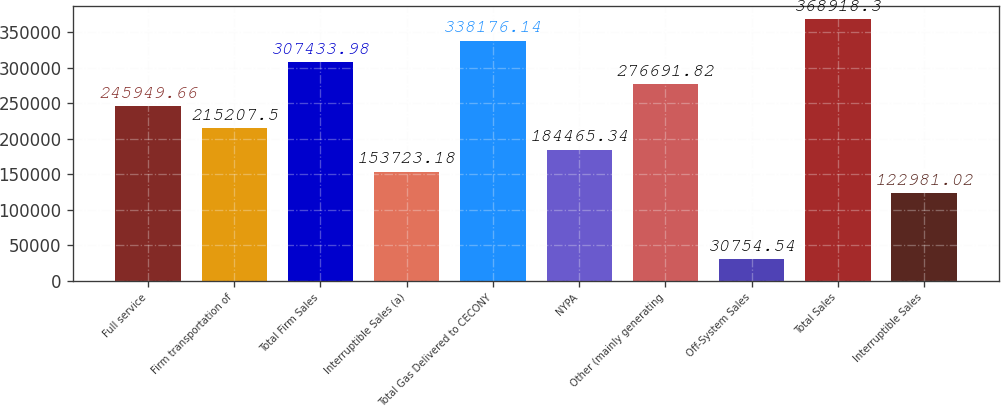<chart> <loc_0><loc_0><loc_500><loc_500><bar_chart><fcel>Full service<fcel>Firm transportation of<fcel>Total Firm Sales<fcel>Interruptible Sales (a)<fcel>Total Gas Delivered to CECONY<fcel>NYPA<fcel>Other (mainly generating<fcel>Off-System Sales<fcel>Total Sales<fcel>Interruptible Sales<nl><fcel>245950<fcel>215208<fcel>307434<fcel>153723<fcel>338176<fcel>184465<fcel>276692<fcel>30754.5<fcel>368918<fcel>122981<nl></chart> 